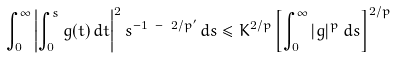<formula> <loc_0><loc_0><loc_500><loc_500>\int _ { 0 } ^ { \infty } \left | \int _ { 0 } ^ { s } g ( t ) \, d t \right | ^ { 2 } s ^ { - 1 \ - \ 2 / p ^ { \prime } } \, d s \leq K ^ { 2 / p } \left [ \int _ { 0 } ^ { \infty } | g | ^ { p } \, d s \right ] ^ { 2 / p }</formula> 